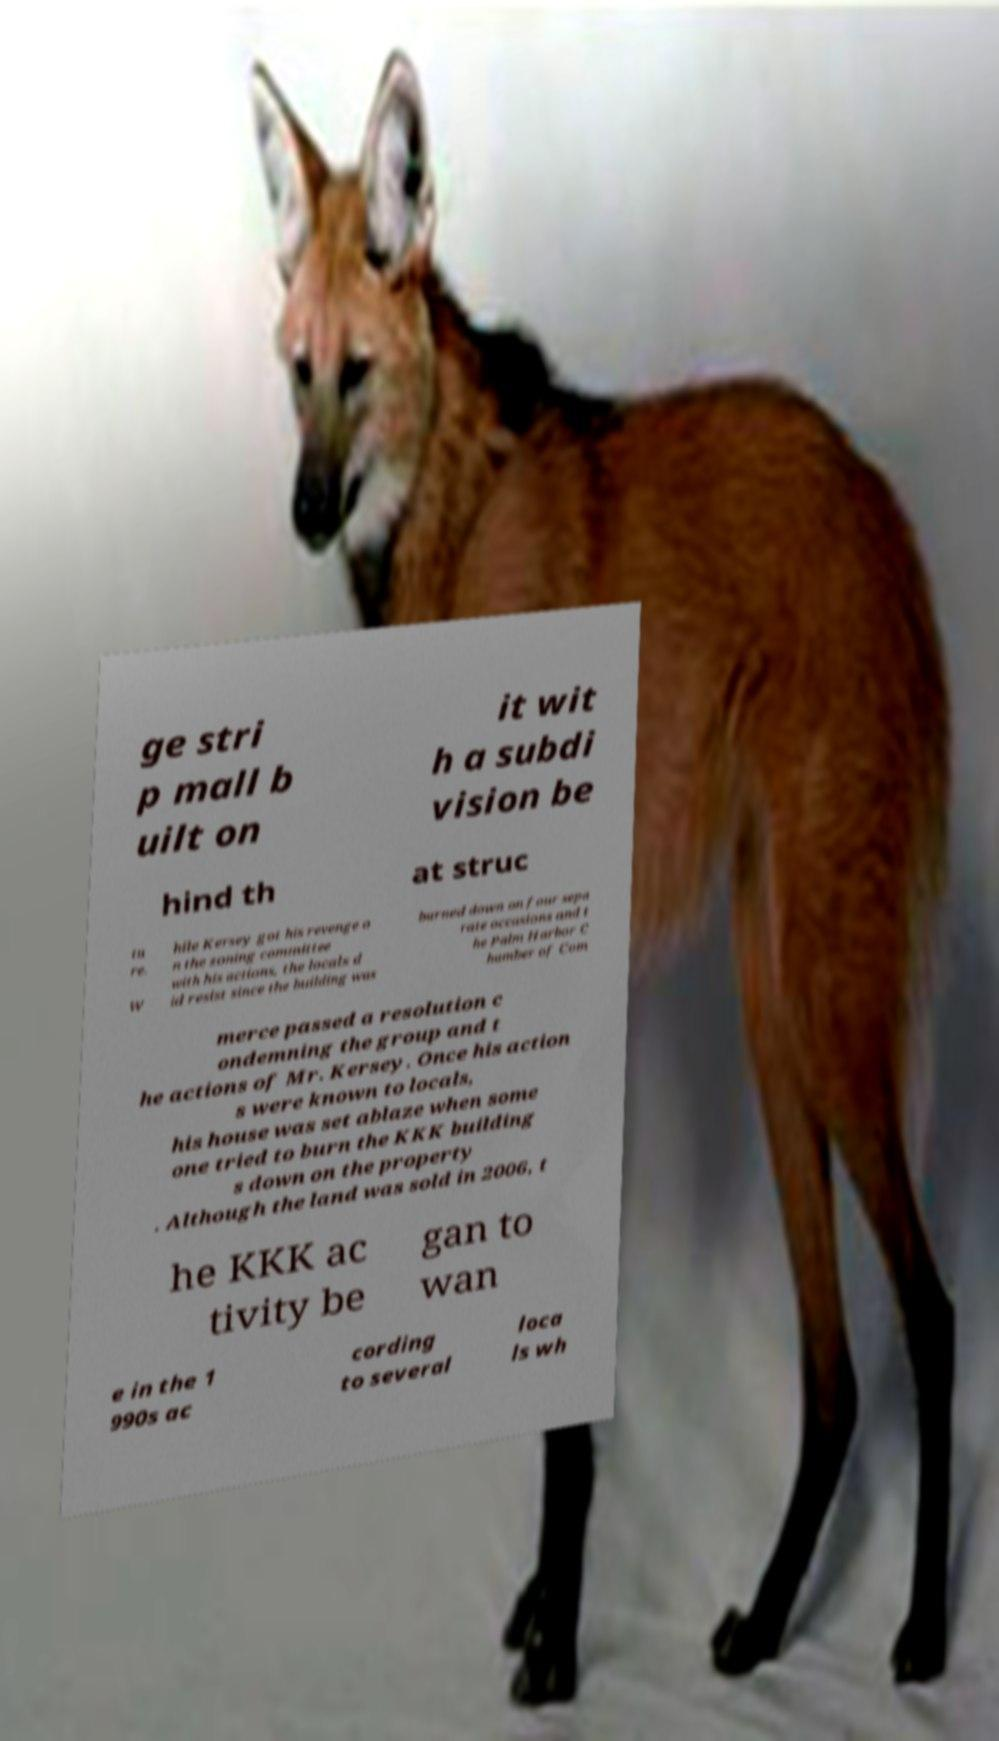Could you extract and type out the text from this image? ge stri p mall b uilt on it wit h a subdi vision be hind th at struc tu re. W hile Kersey got his revenge o n the zoning committee with his actions, the locals d id resist since the building was burned down on four sepa rate occasions and t he Palm Harbor C hamber of Com merce passed a resolution c ondemning the group and t he actions of Mr. Kersey. Once his action s were known to locals, his house was set ablaze when some one tried to burn the KKK building s down on the property . Although the land was sold in 2006, t he KKK ac tivity be gan to wan e in the 1 990s ac cording to several loca ls wh 